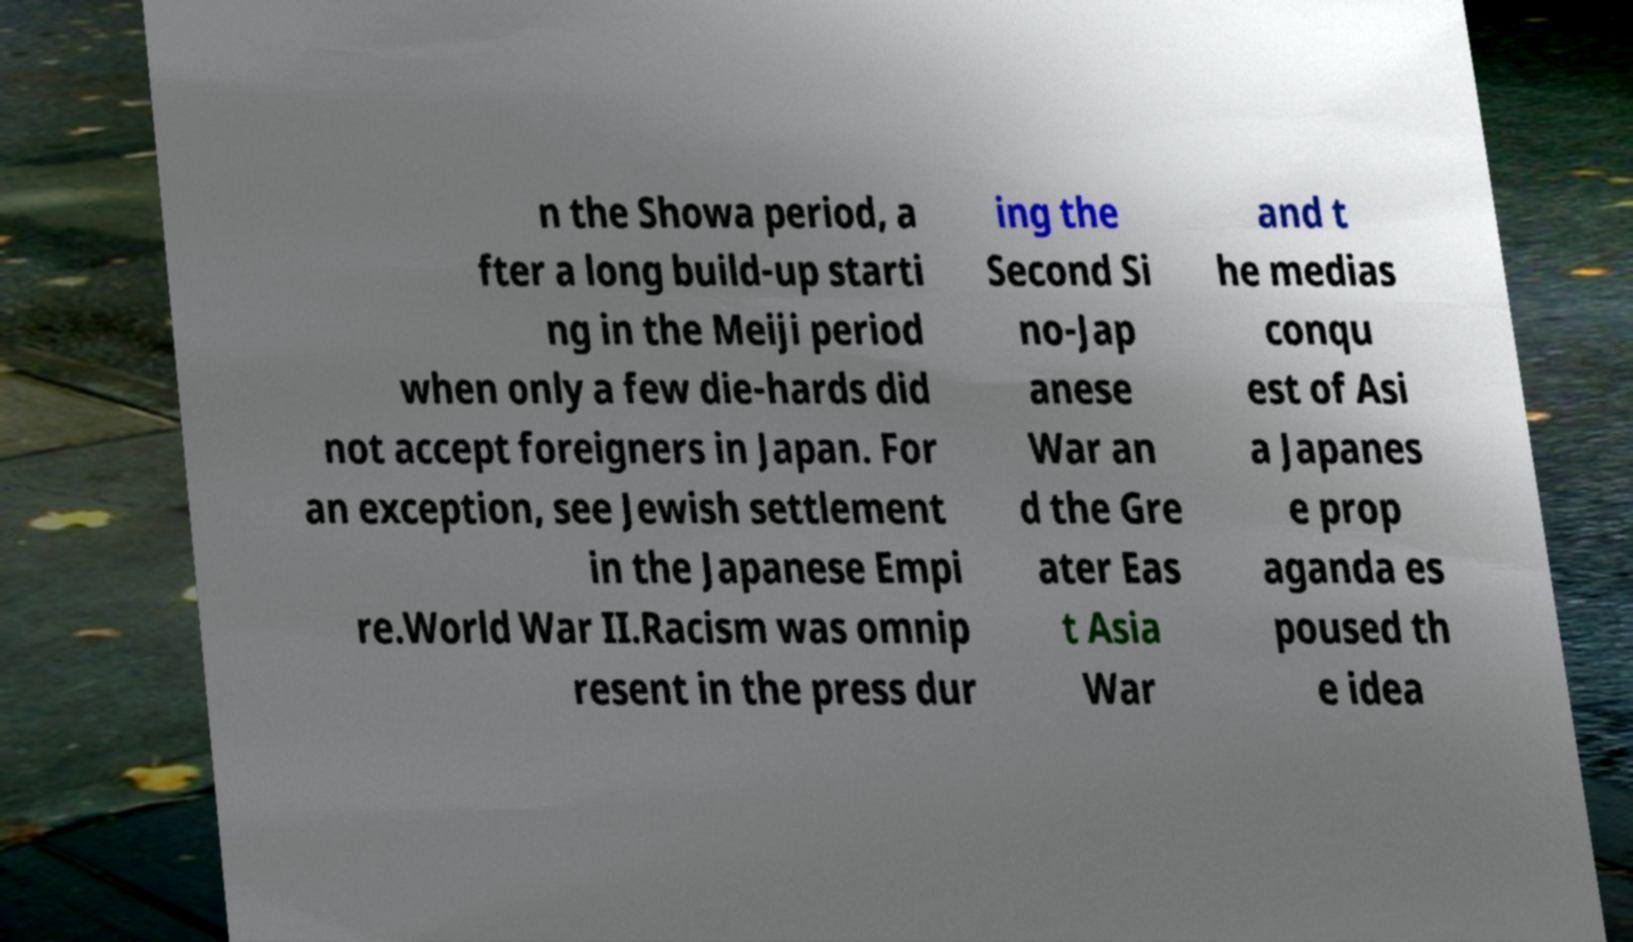What messages or text are displayed in this image? I need them in a readable, typed format. n the Showa period, a fter a long build-up starti ng in the Meiji period when only a few die-hards did not accept foreigners in Japan. For an exception, see Jewish settlement in the Japanese Empi re.World War II.Racism was omnip resent in the press dur ing the Second Si no-Jap anese War an d the Gre ater Eas t Asia War and t he medias conqu est of Asi a Japanes e prop aganda es poused th e idea 